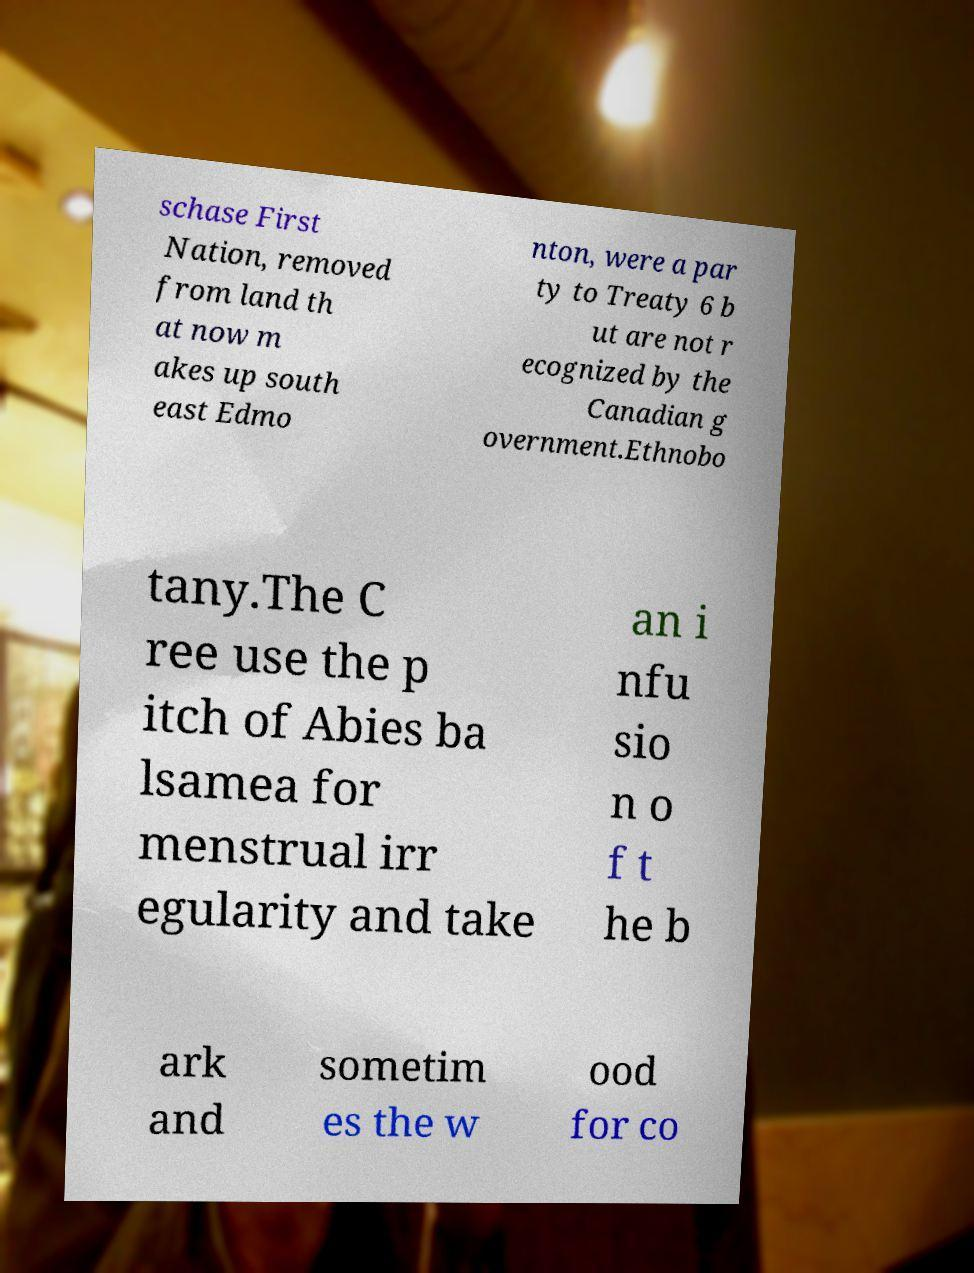Please read and relay the text visible in this image. What does it say? schase First Nation, removed from land th at now m akes up south east Edmo nton, were a par ty to Treaty 6 b ut are not r ecognized by the Canadian g overnment.Ethnobo tany.The C ree use the p itch of Abies ba lsamea for menstrual irr egularity and take an i nfu sio n o f t he b ark and sometim es the w ood for co 